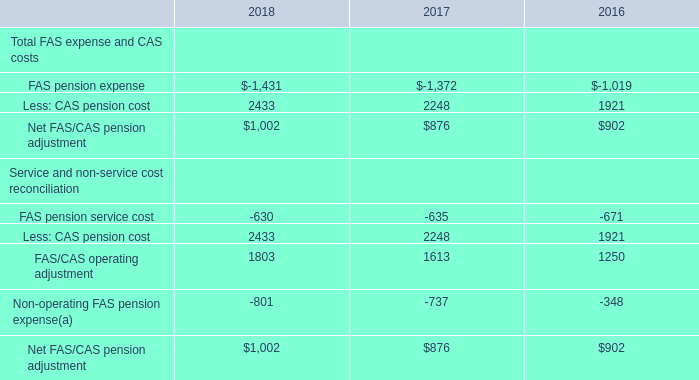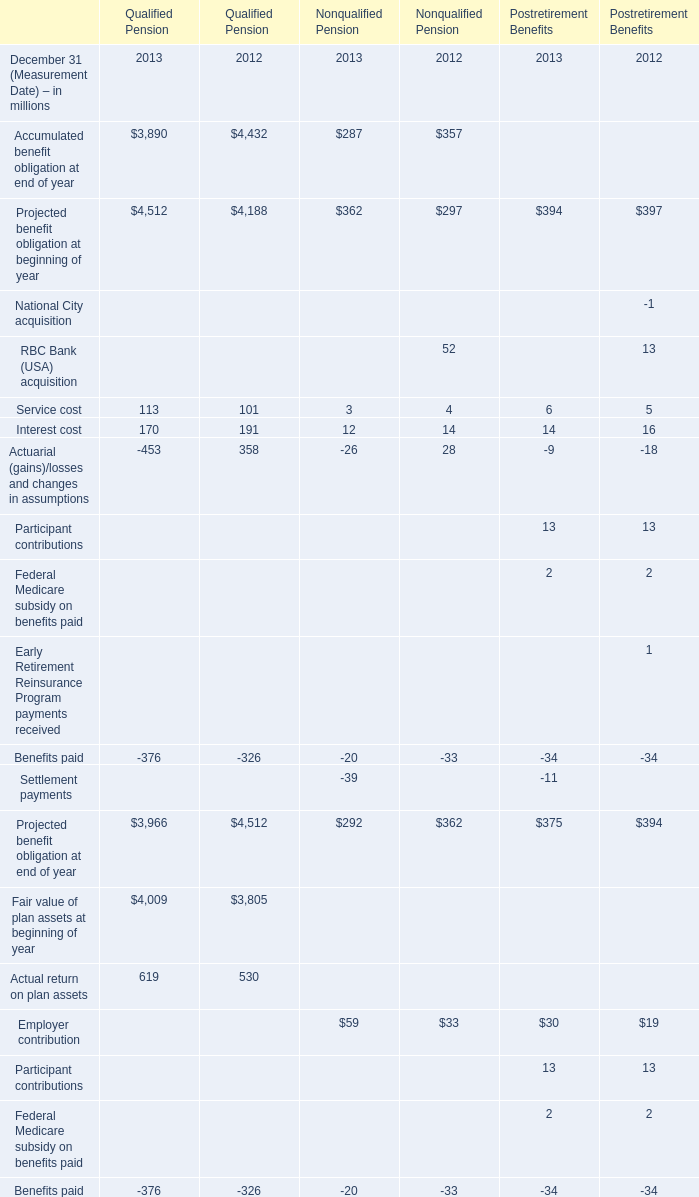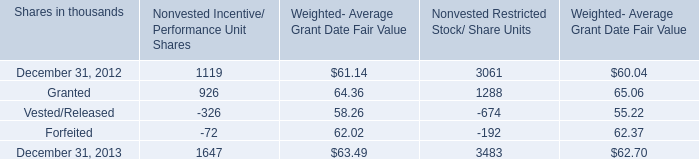what was the total fair value of incentive/performance unit share and restricted stock/unit awards vested during 2013 and 2012 in millions? 
Computations: (63 + 55)
Answer: 118.0. 